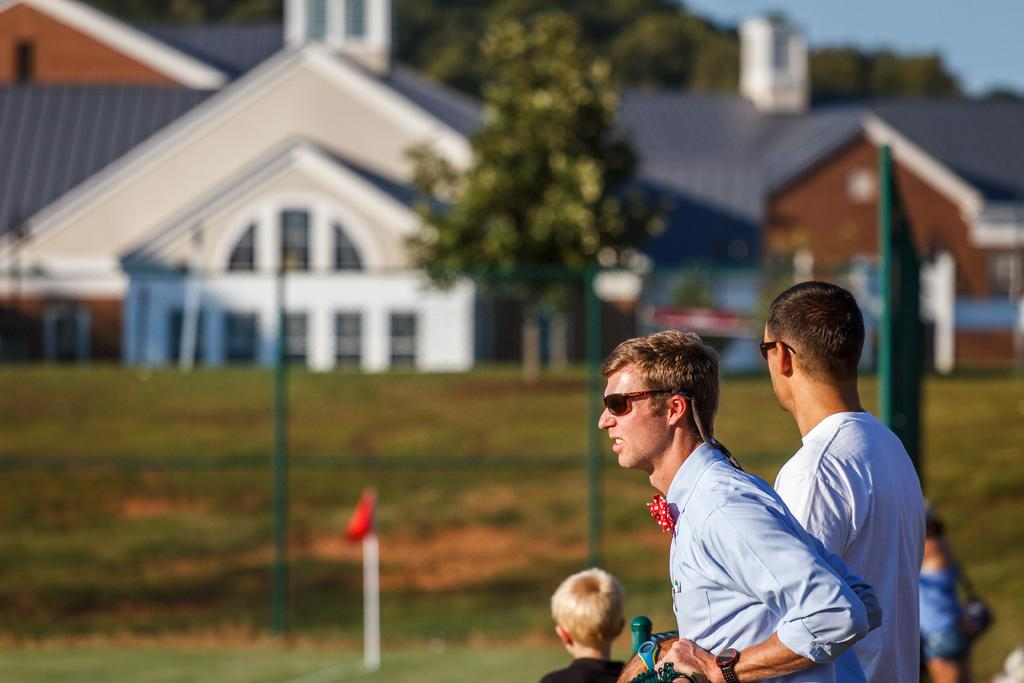How many men are in the image? There are two men on the right side of the image. What are the men doing in the image? The men are looking towards the left side of the image. What structure is located in the middle of the image? There is a house in the middle of the image. What type of vegetation is present in the image? There are trees in the image. What type of magic is being performed by the men in the image? There is no indication of magic or any magical activity in the image. The men are simply looking towards the left side of the image. 